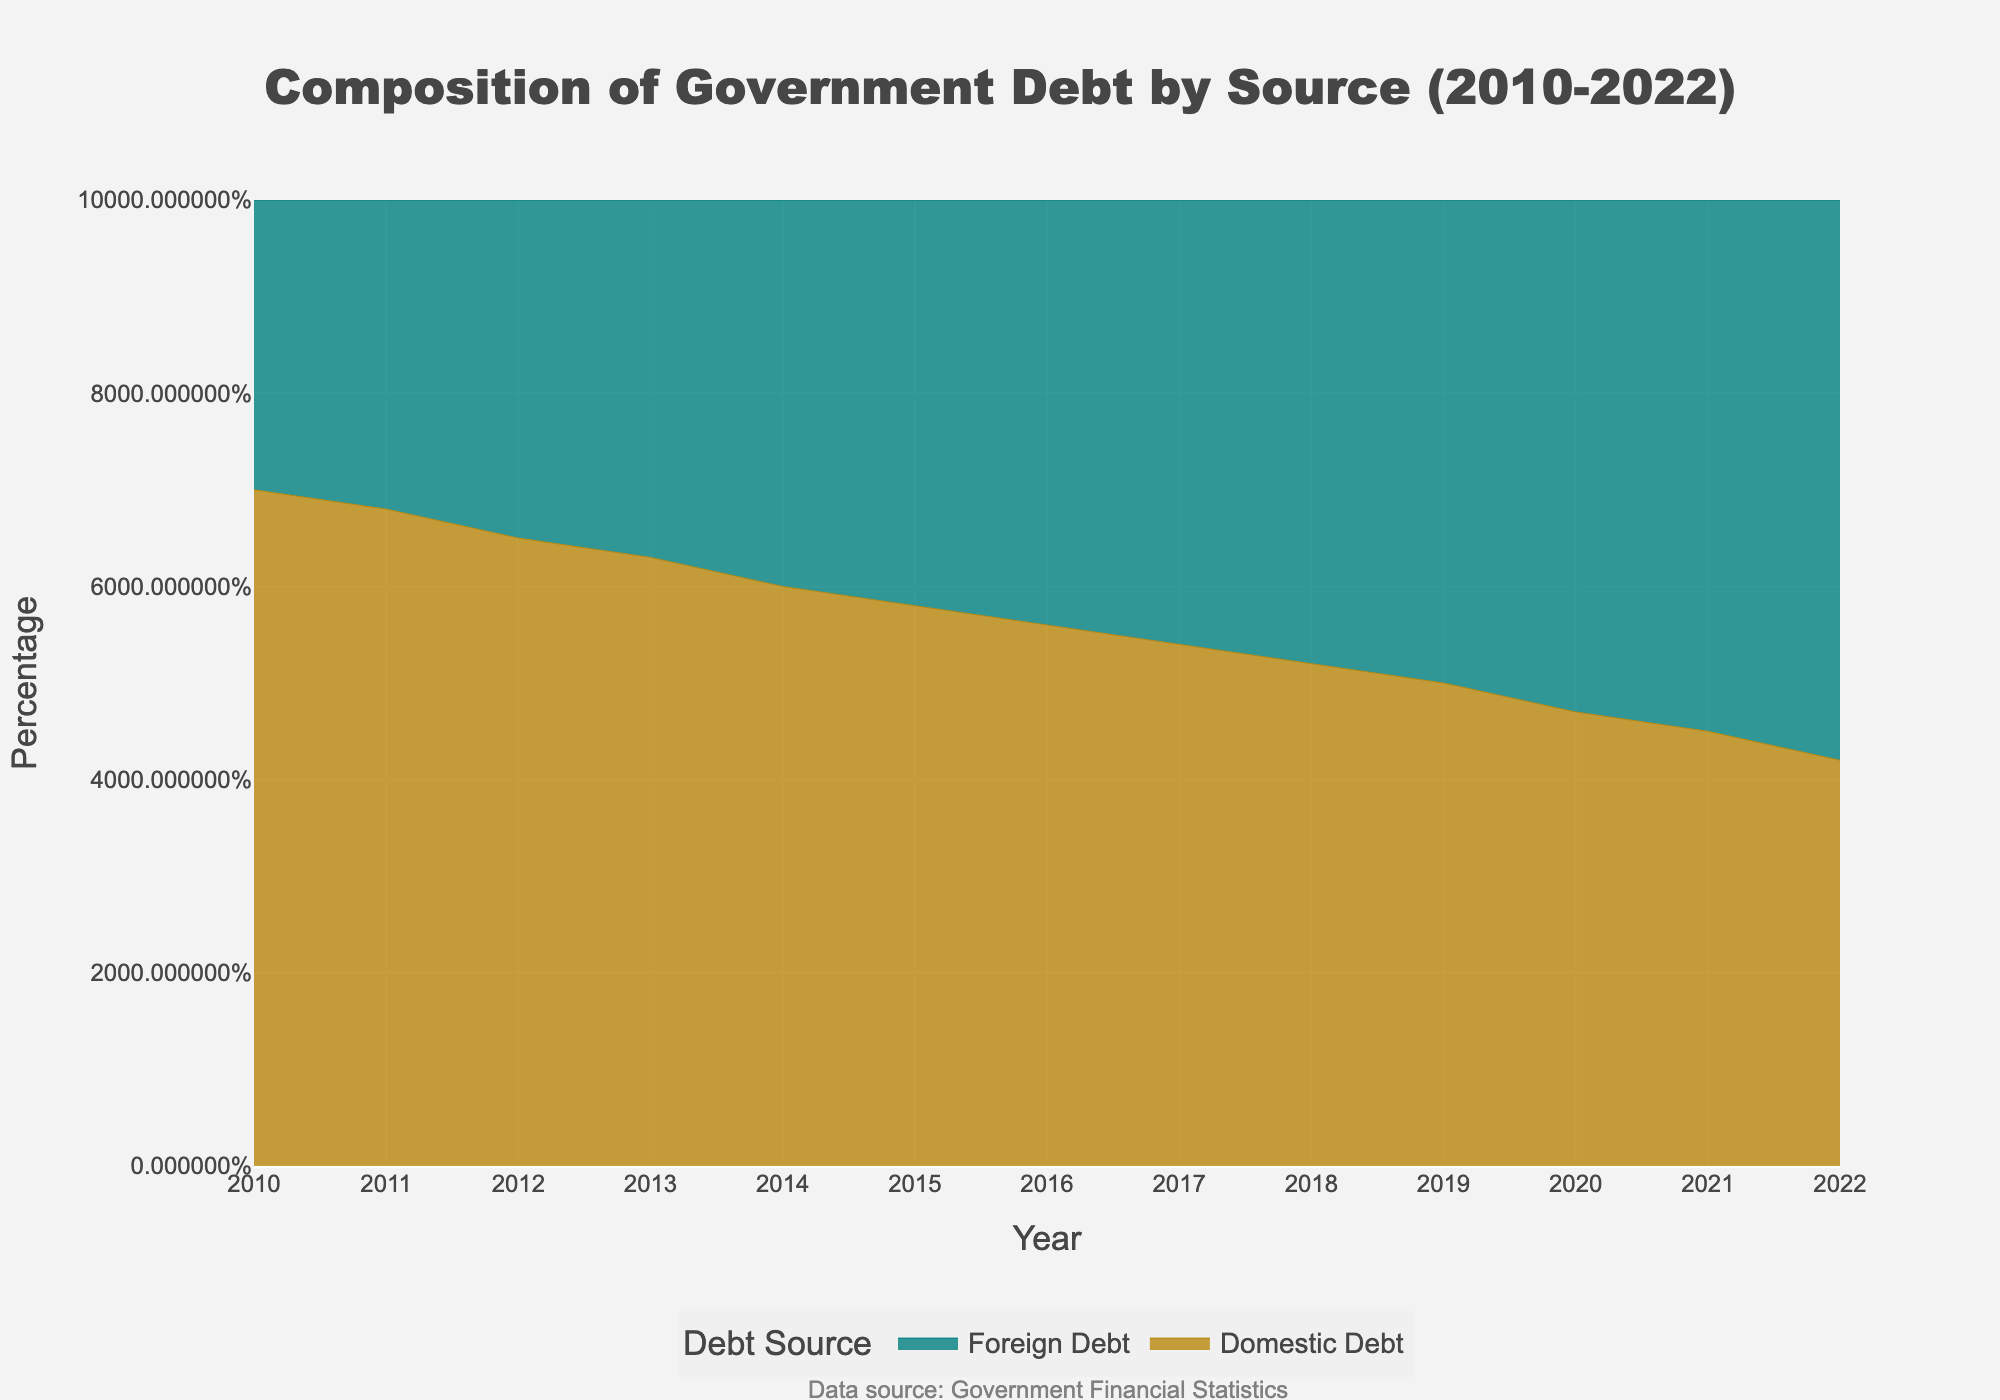What is the title of the figure? The title is displayed at the top of the figure. It reads, "Composition of Government Debt by Source (2010-2022)."
Answer: Composition of Government Debt by Source (2010-2022) What are the two types of debt shown in the figure? The two types of debt highlighted in the legend are "Domestic Debt" and "Foreign Debt."
Answer: Domestic Debt and Foreign Debt What is the color used to represent Domestic Debt? The color used for Domestic Debt can be seen in the lines and area of the figs. It's a shade of gold.
Answer: Gold In which year does Foreign Debt first exceed Domestic Debt? Examine the plot lines for both debt types. Foreign Debt first exceeds Domestic Debt in the year 2019.
Answer: 2019 Which year has an equal proportion of Domestic and Foreign Debt? Both areas intersect at the 50% mark, indicating equal proportions, which occurs in 2019.
Answer: 2019 How has the percentage of Domestic Debt changed from 2010 to 2022? The plot shows a line representing Domestic Debt. Starting at 70% in 2010, it decreases to 42% in 2022.
Answer: Decreased by 28% What is the trend in Foreign Debt from 2010 to 2022? Observing the area representing Foreign Debt, it shows a consistent rise from 30% in 2010 to 58% in 2022.
Answer: Increased Was the percentage of Domestic Debt ever constant at any point between 2010 and 2022? The plot indicates a continuous change in Domestic Debt's percentage without any flat sections.
Answer: No What was the percentage of Foreign Debt in 2016? Locate the value on the stack area for Foreign Debt at 2016. It is marked at 44%.
Answer: 44% How much did the percentage of Foreign Debt increase between 2020 and 2022? The percentage of Foreign Debt was 53% in 2020 and 58% in 2022. The difference is 58% - 53%, which is 5%.
Answer: 5% 